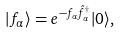Convert formula to latex. <formula><loc_0><loc_0><loc_500><loc_500>| f _ { \alpha } \rangle = e ^ { - f _ { \alpha } \hat { f } ^ { \dagger } _ { \alpha } } | 0 \rangle ,</formula> 